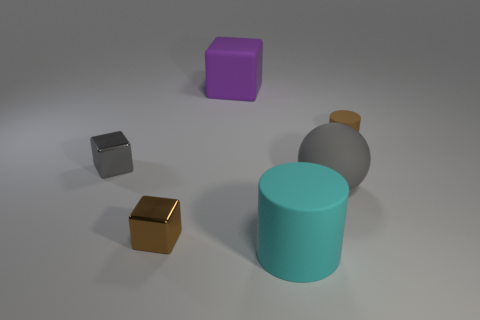Does the lighting in the picture suggest a particular time of day or setting? The lighting in the image is neutral and does not suggest a particular time of day. It appears to be a controlled, perhaps artificial lighting, typical of an indoor setting or a studio environment. 